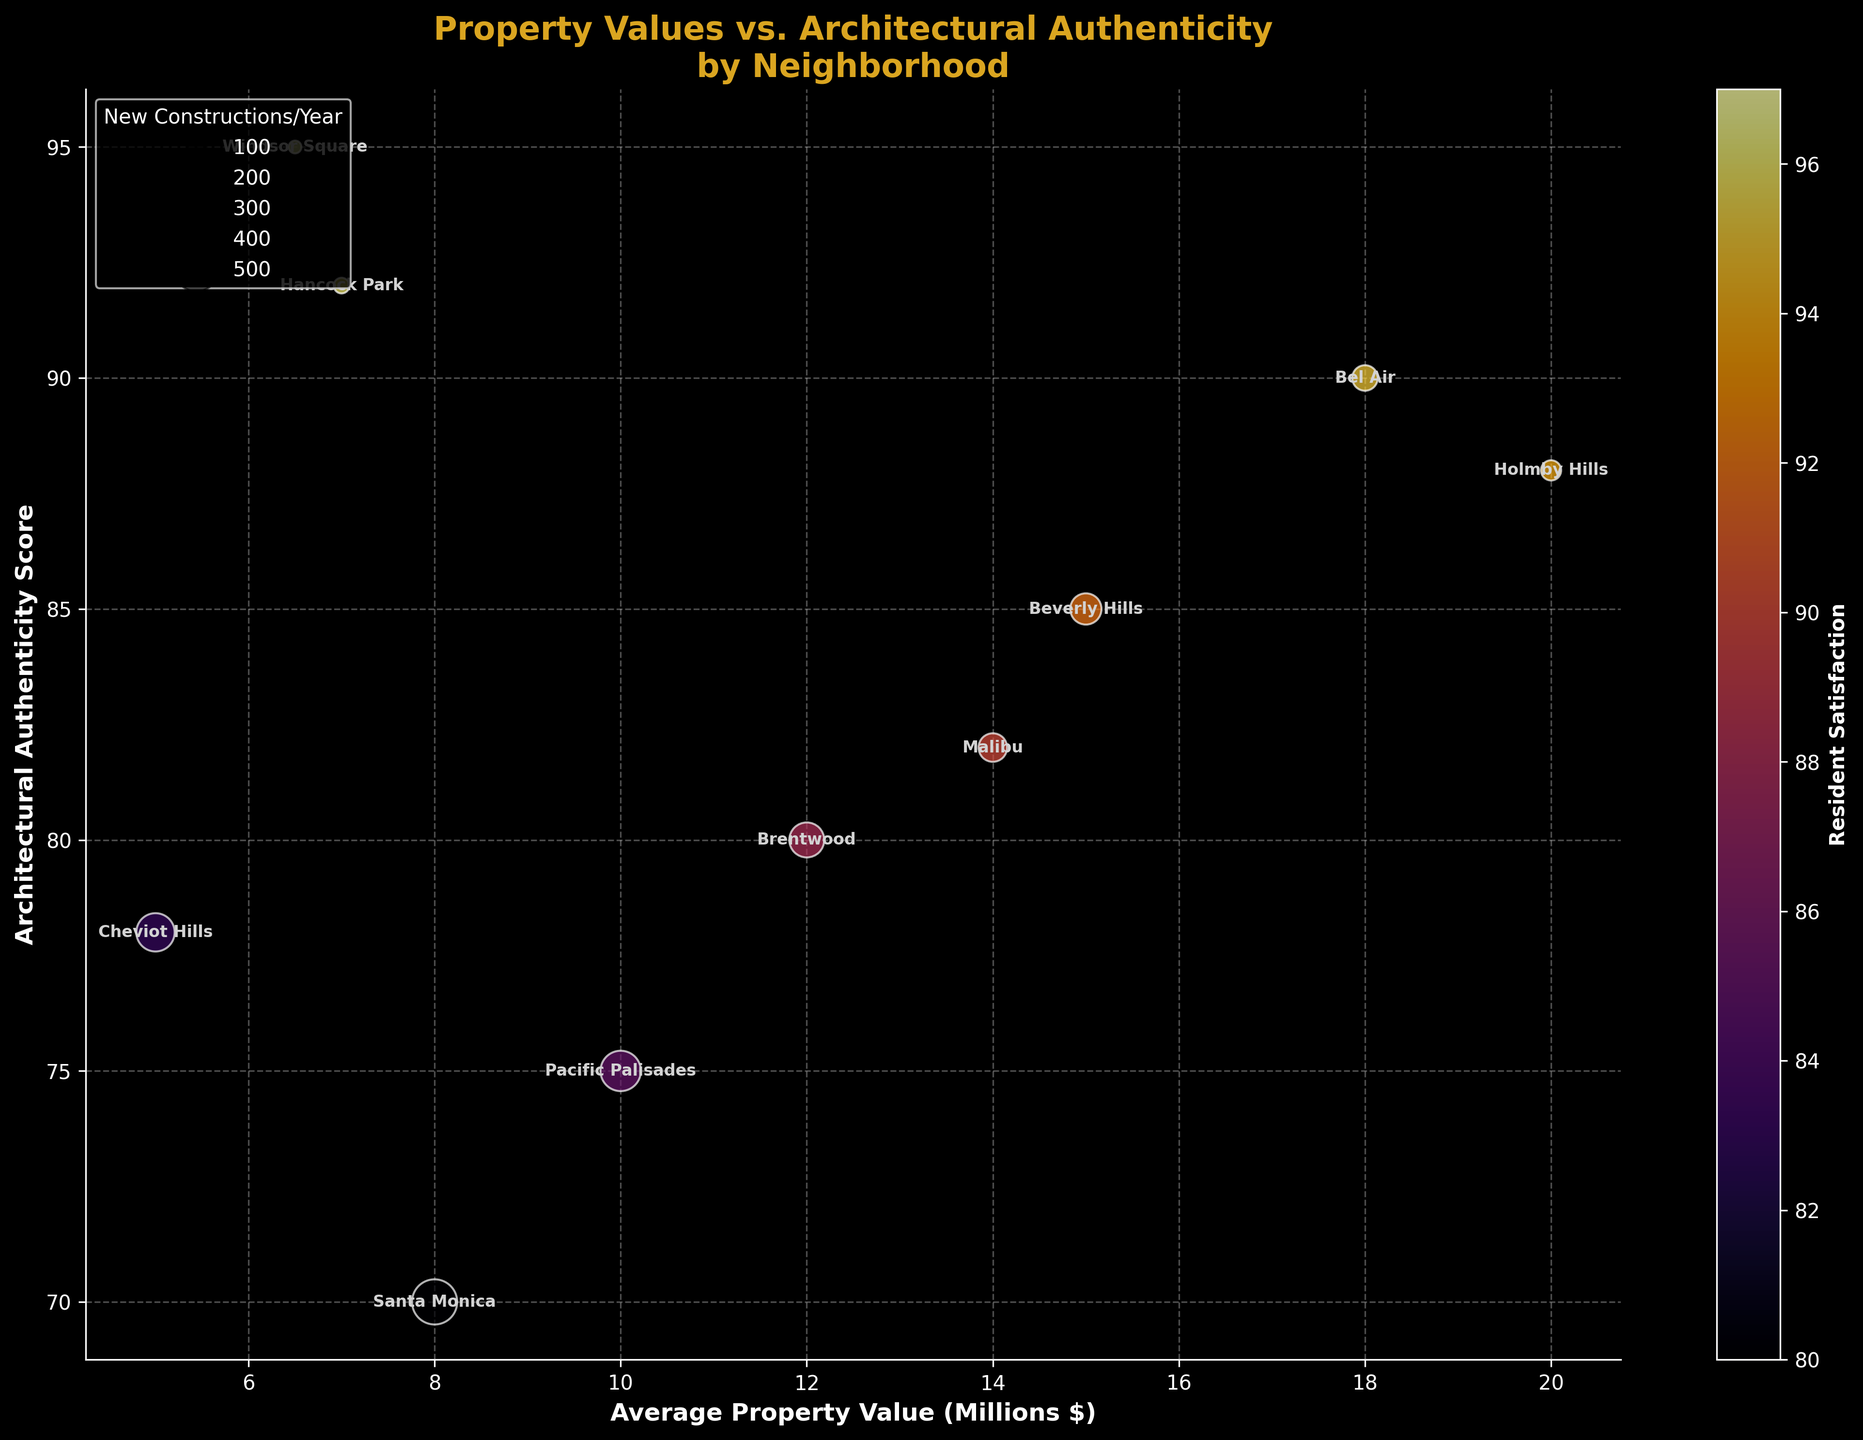What's the title of the figure? The title is usually displayed at the top of the figure. It concisely describes what the figure is about.
Answer: Property Values vs. Architectural Authenticity by Neighborhood How many neighborhoods are represented in the figure? Count the number of distinct data points (bubbles) plotted in the figure. Each bubble represents a different neighborhood.
Answer: 10 Which neighborhood has the highest architectural authenticity score? Look at the y-axis (Architectural Authenticity Score) and identify the highest point. Check the neighborhood label adjacent to that point.
Answer: Windsor Square What is the average property value in Malibu (in millions of dollars)? Find the bubble with the label "Malibu" and check its position on the x-axis (Average Property Value in millions of dollars).
Answer: 14 Which neighborhoods have architectural authenticity scores greater than 90? Identify the bubbles that lie above the y-axis value of 90 and note their labels.
Answer: Hancock Park, Windsor Square How does resident satisfaction relate to architectural authenticity scores across the neighborhoods? Observe if there is a trend where bubbles with higher y-values (Architectural Authenticity Score) have consistently higher colors (indicating higher Resident Satisfaction).
Answer: Higher architectural authenticity generally correlates with higher resident satisfaction Compare the average property values of Pacific Palisades and Santa Monica. Which is higher? Check the x-axis values (Average Property Value in millions of dollars) for the bubbles labeled "Pacific Palisades" and "Santa Monica", and compare them.
Answer: Pacific Palisades Which neighborhood has the fewest new constructions per year and how does it impact its resident satisfaction? Identify the smallest bubble (representing the least number of new constructions) and note its label and color (indicating resident satisfaction).
Answer: Windsor Square; high satisfaction Is there an outlier in terms of both property value and architectural authenticity? Look for a bubble that stands out distinctly in terms of its position on the x-axis and y-axis, indicating extreme values for both attributes.
Answer: Holmby Hills (highest property value with high authenticity) What's the total number of new constructions per year across all neighborhoods? Sum the "New Constructions per Year" values for all the neighborhoods. 12 + 8 + 5 + 20 + 15 + 10 + 25 + 3 + 2 + 18 = 118
Answer: 118 